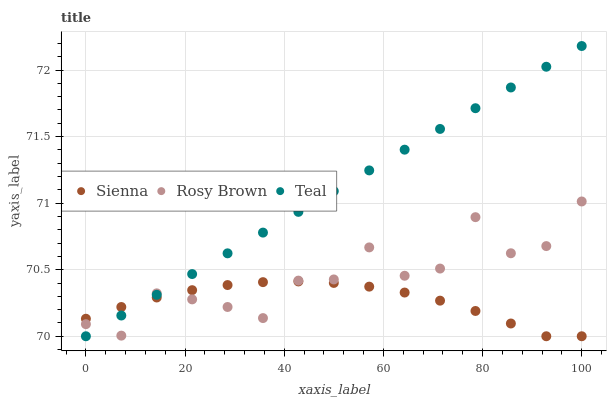Does Sienna have the minimum area under the curve?
Answer yes or no. Yes. Does Teal have the maximum area under the curve?
Answer yes or no. Yes. Does Rosy Brown have the minimum area under the curve?
Answer yes or no. No. Does Rosy Brown have the maximum area under the curve?
Answer yes or no. No. Is Teal the smoothest?
Answer yes or no. Yes. Is Rosy Brown the roughest?
Answer yes or no. Yes. Is Rosy Brown the smoothest?
Answer yes or no. No. Is Teal the roughest?
Answer yes or no. No. Does Sienna have the lowest value?
Answer yes or no. Yes. Does Rosy Brown have the lowest value?
Answer yes or no. No. Does Teal have the highest value?
Answer yes or no. Yes. Does Rosy Brown have the highest value?
Answer yes or no. No. Does Teal intersect Sienna?
Answer yes or no. Yes. Is Teal less than Sienna?
Answer yes or no. No. Is Teal greater than Sienna?
Answer yes or no. No. 